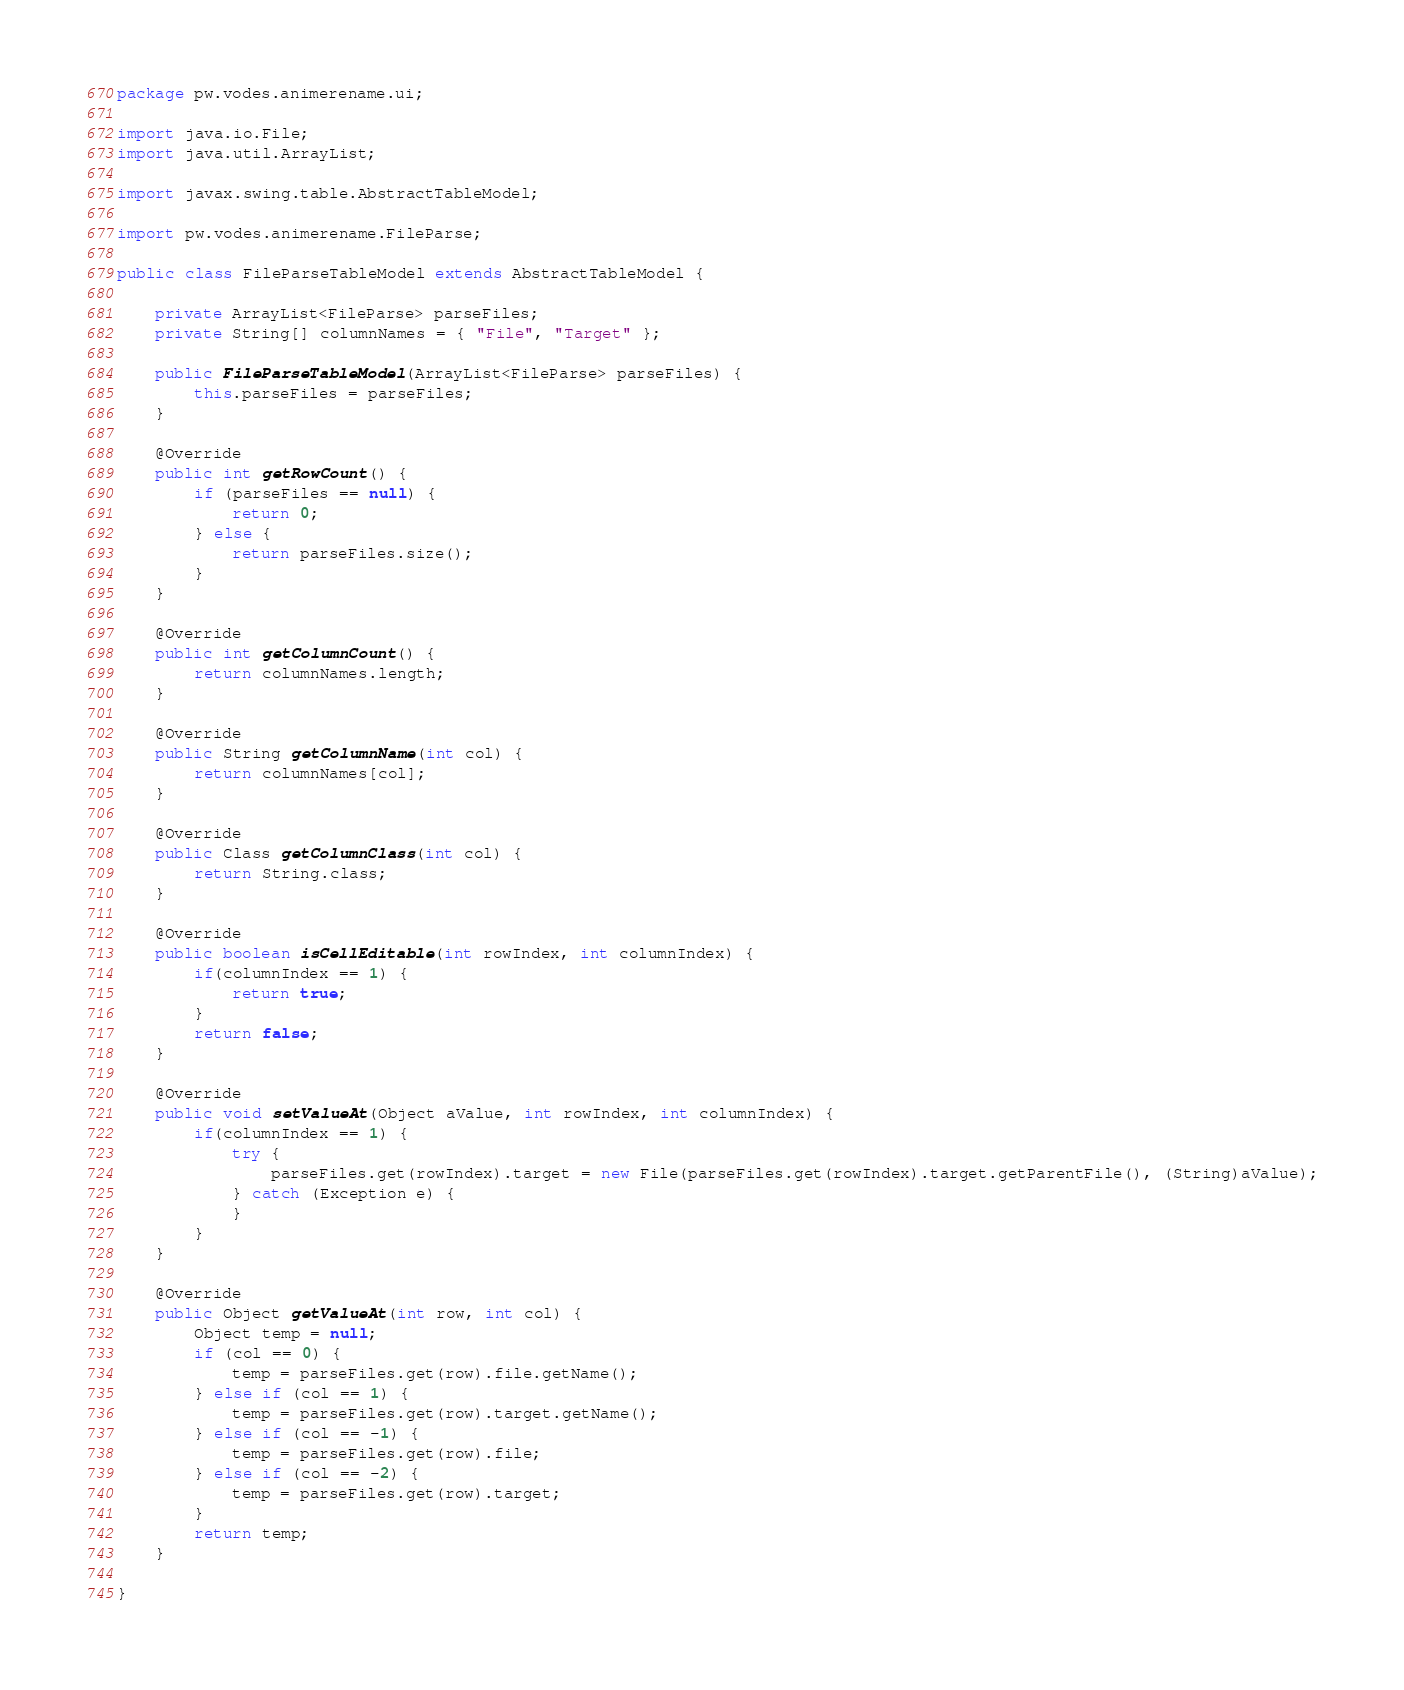Convert code to text. <code><loc_0><loc_0><loc_500><loc_500><_Java_>package pw.vodes.animerename.ui;

import java.io.File;
import java.util.ArrayList;

import javax.swing.table.AbstractTableModel;

import pw.vodes.animerename.FileParse;

public class FileParseTableModel extends AbstractTableModel {

	private ArrayList<FileParse> parseFiles;
	private String[] columnNames = { "File", "Target" };

	public FileParseTableModel(ArrayList<FileParse> parseFiles) {
		this.parseFiles = parseFiles;
	}

	@Override
	public int getRowCount() {
		if (parseFiles == null) {
			return 0;
		} else {
			return parseFiles.size();
		}
	}

	@Override
	public int getColumnCount() {
		return columnNames.length;
	}

	@Override
	public String getColumnName(int col) {
		return columnNames[col];
	}

	@Override
	public Class getColumnClass(int col) {
		return String.class;
	}
	
	@Override
	public boolean isCellEditable(int rowIndex, int columnIndex) {
		if(columnIndex == 1) {
			return true;
		}
		return false;
	}
	
	@Override
	public void setValueAt(Object aValue, int rowIndex, int columnIndex) {
		if(columnIndex == 1) {
			try {
				parseFiles.get(rowIndex).target = new File(parseFiles.get(rowIndex).target.getParentFile(), (String)aValue);
			} catch (Exception e) {
			}
		}
	}

	@Override
	public Object getValueAt(int row, int col) {
		Object temp = null;
		if (col == 0) {
			temp = parseFiles.get(row).file.getName();
		} else if (col == 1) {
			temp = parseFiles.get(row).target.getName();
		} else if (col == -1) {
			temp = parseFiles.get(row).file;
		} else if (col == -2) {
			temp = parseFiles.get(row).target;
		}
		return temp;
	}

}
</code> 